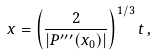Convert formula to latex. <formula><loc_0><loc_0><loc_500><loc_500>x = \left ( \frac { 2 } { | P ^ { \prime \prime \prime } ( x _ { 0 } ) | } \right ) ^ { 1 / 3 } t \, ,</formula> 